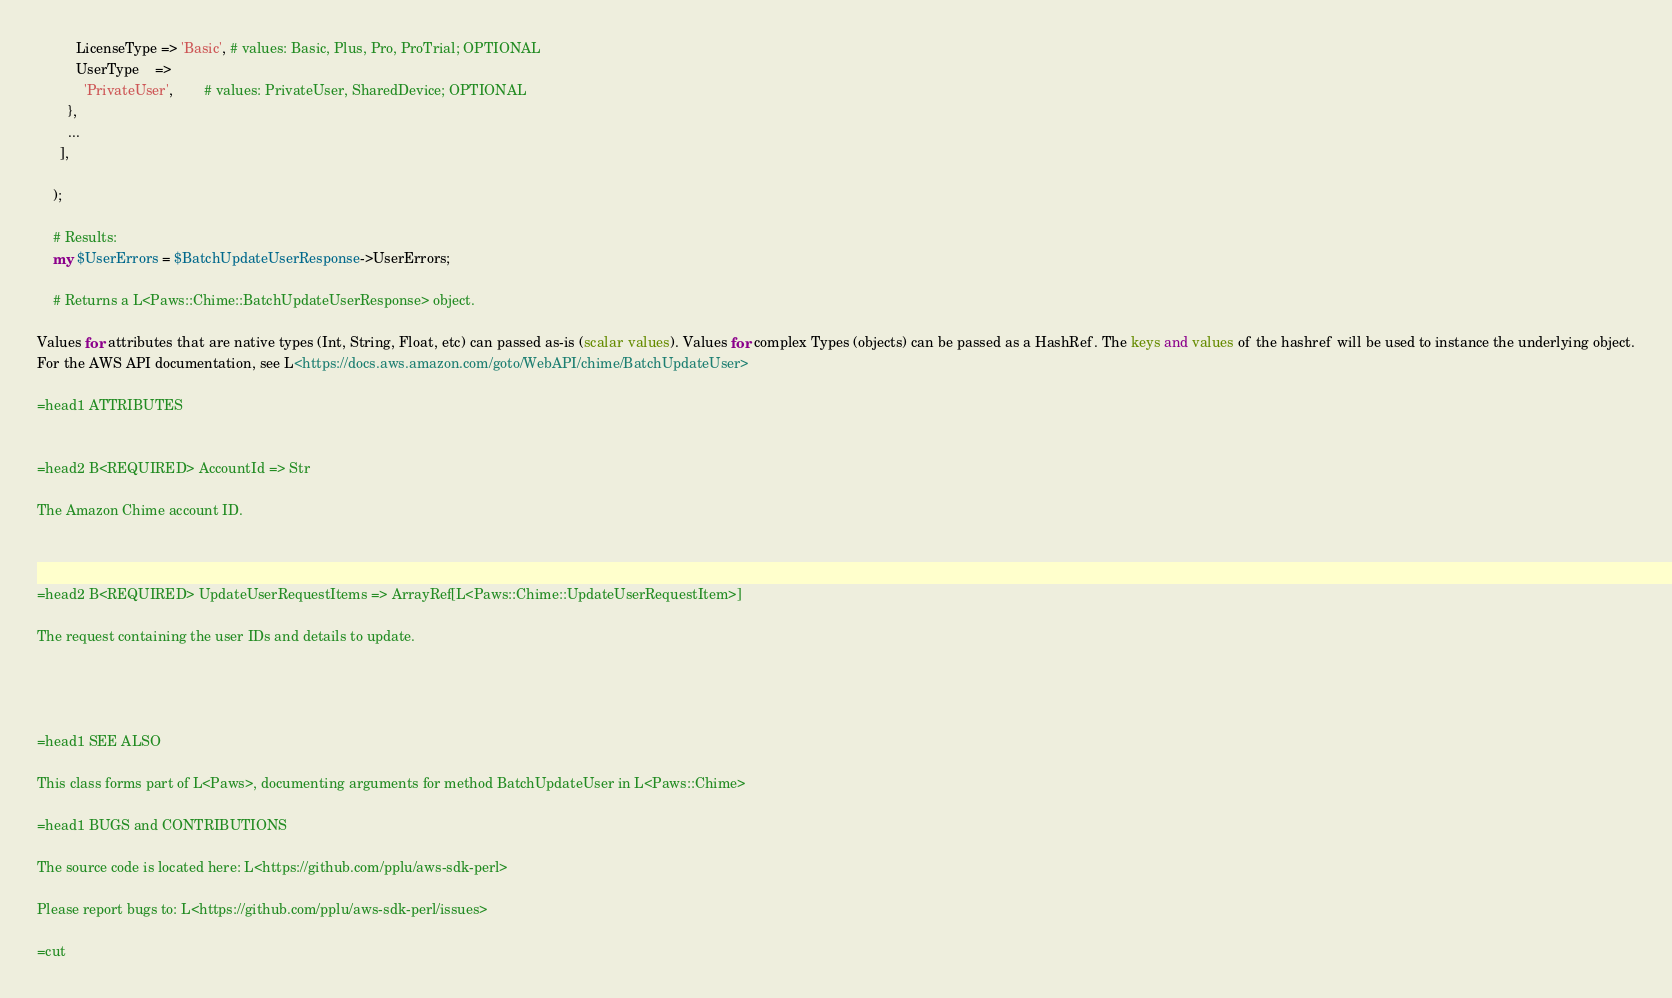Convert code to text. <code><loc_0><loc_0><loc_500><loc_500><_Perl_>          LicenseType => 'Basic', # values: Basic, Plus, Pro, ProTrial; OPTIONAL
          UserType    =>
            'PrivateUser',        # values: PrivateUser, SharedDevice; OPTIONAL
        },
        ...
      ],

    );

    # Results:
    my $UserErrors = $BatchUpdateUserResponse->UserErrors;

    # Returns a L<Paws::Chime::BatchUpdateUserResponse> object.

Values for attributes that are native types (Int, String, Float, etc) can passed as-is (scalar values). Values for complex Types (objects) can be passed as a HashRef. The keys and values of the hashref will be used to instance the underlying object.
For the AWS API documentation, see L<https://docs.aws.amazon.com/goto/WebAPI/chime/BatchUpdateUser>

=head1 ATTRIBUTES


=head2 B<REQUIRED> AccountId => Str

The Amazon Chime account ID.



=head2 B<REQUIRED> UpdateUserRequestItems => ArrayRef[L<Paws::Chime::UpdateUserRequestItem>]

The request containing the user IDs and details to update.




=head1 SEE ALSO

This class forms part of L<Paws>, documenting arguments for method BatchUpdateUser in L<Paws::Chime>

=head1 BUGS and CONTRIBUTIONS

The source code is located here: L<https://github.com/pplu/aws-sdk-perl>

Please report bugs to: L<https://github.com/pplu/aws-sdk-perl/issues>

=cut

</code> 